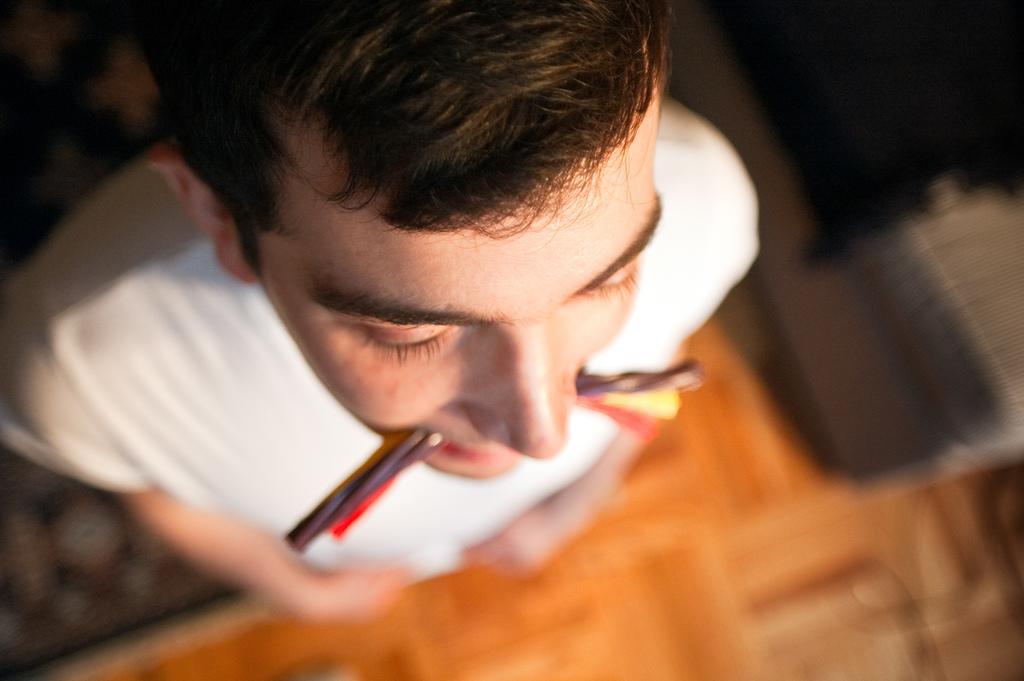How would you summarize this image in a sentence or two? In this picture we can see a man standing on the floor, wearing a white t-shirt and he is holding some colorful object in his mouth. Remaining portion of the picture is blur. 